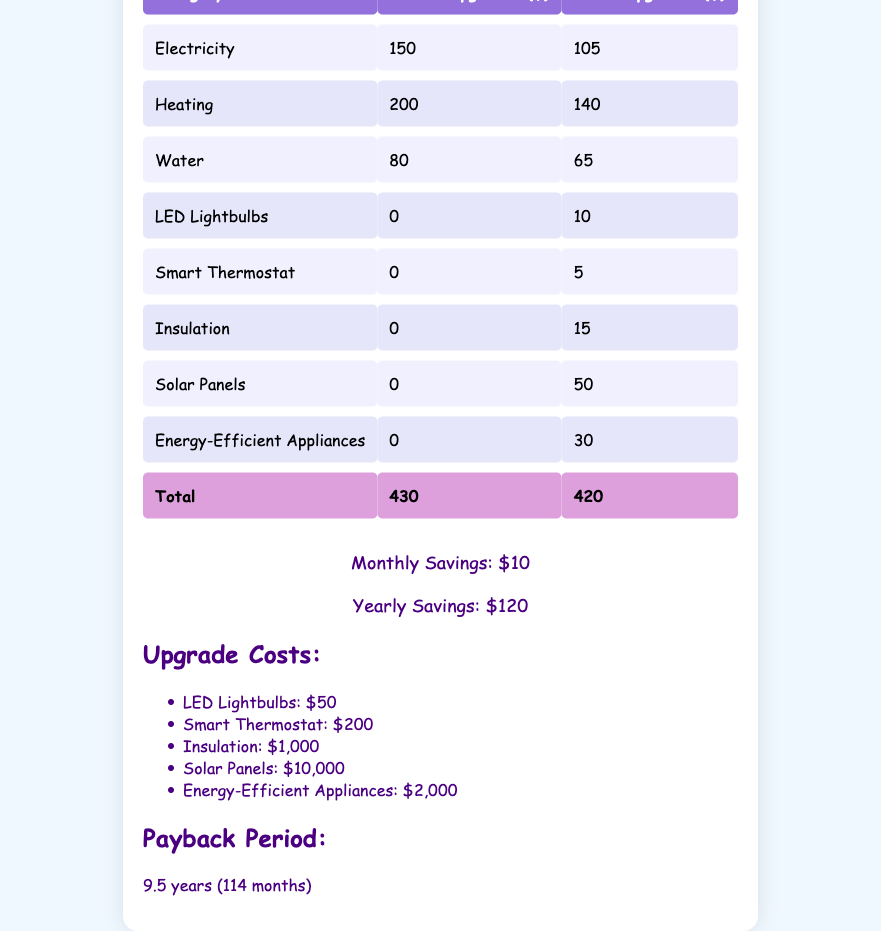What was the monthly electricity expense before the upgrades? The table shows the 'Electricity' category under the 'Before Upgrades' column. The value is 150.
Answer: 150 What is the total monthly expense after the upgrades? The table indicates the 'Total' row under the 'After Upgrades' column, with a value of 420.
Answer: 420 Is the monthly expense lower after the upgrades as compared to before? By comparing the 'Total' values from both 'Before Upgrades' (430) and 'After Upgrades' (420), we see that 420 is less than 430. Thus, the monthly expense is indeed lower after the upgrades.
Answer: Yes What is the savings in heating expenses after the upgrades? For the 'Heating' category, the 'Before Upgrades' expense is 200 and the 'After Upgrades' expense is 140. To find the savings, subtract 140 from 200, which gives us 60.
Answer: 60 What is the total amount spent on energy-saving upgrades? The table lists the costs for five different upgrades. Adding these values together: 50 (LED Lightbulbs) + 200 (Smart Thermostat) + 1000 (Insulation) + 10000 (Solar Panels) + 2000 (Energy-Efficient Appliances) equals 12,250.
Answer: 12250 Which household expense category had the highest savings after the upgrades? Comparing the before and after expenses for all categories shows that 'Heating' had the highest savings of 60, as it went from 200 to 140.
Answer: Heating If the savings continue, how many years will it take to recoup the total upgrade costs? The payback period is stated in the data as 9.5 years. This is the duration needed to recover the costs based on the monthly savings of 10.
Answer: 9.5 years Did the family spend more on 'LED Lightbulbs' after the upgrades? According to the table, there was no expense for 'LED Lightbulbs' before the upgrades (0) and then a charge of 10 after the upgrades. Therefore, they started spending on it post-upgrades, indicating an increase.
Answer: Yes What is the percentage reduction in total monthly expenses due to the upgrades? The initial total was 430 and the new total is 420. The reduction is 430 - 420 = 10. To find the percentage reduction, divide 10 by 430 and multiply by 100, which yields approximately 2.33%.
Answer: Approximately 2.33% 